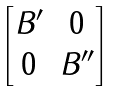<formula> <loc_0><loc_0><loc_500><loc_500>\begin{bmatrix} B ^ { \prime } & 0 \\ 0 & B ^ { \prime \prime } \end{bmatrix}</formula> 